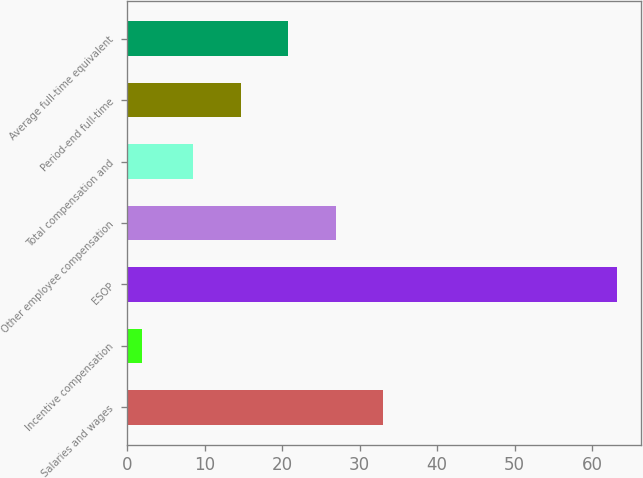Convert chart to OTSL. <chart><loc_0><loc_0><loc_500><loc_500><bar_chart><fcel>Salaries and wages<fcel>Incentive compensation<fcel>ESOP<fcel>Other employee compensation<fcel>Total compensation and<fcel>Period-end full-time<fcel>Average full-time equivalent<nl><fcel>33.02<fcel>1.9<fcel>63.2<fcel>26.89<fcel>8.5<fcel>14.63<fcel>20.76<nl></chart> 